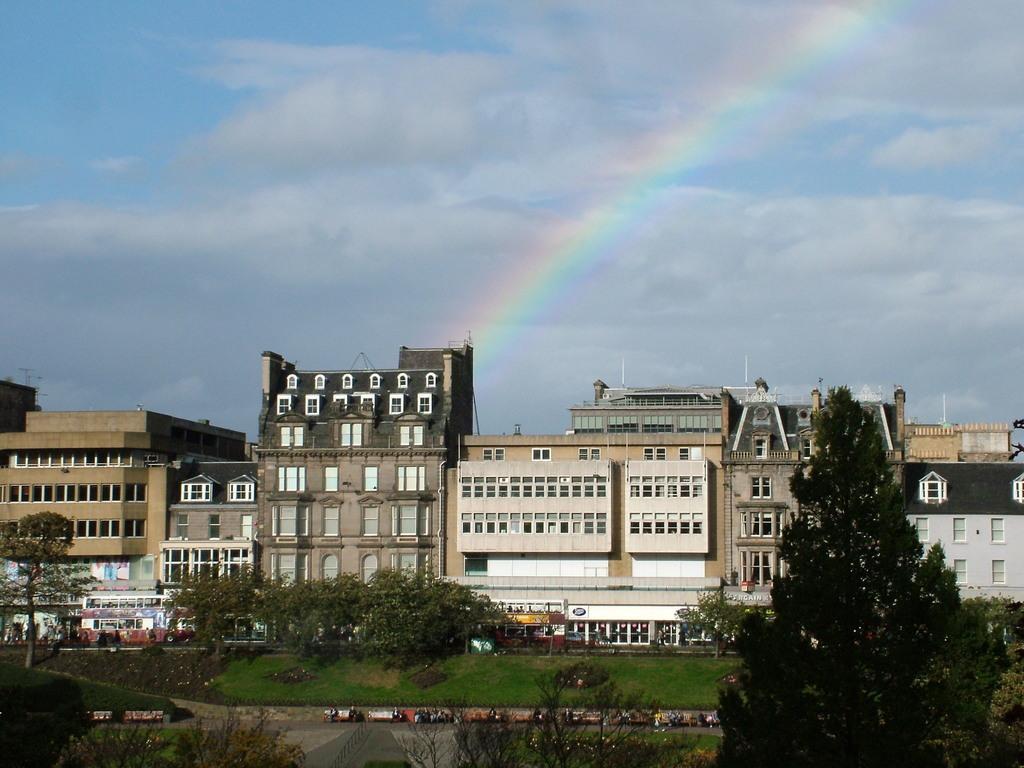How would you summarize this image in a sentence or two? In this image, we can see vehicles on the road and in the background, there are trees and buildings. At the bottom, there is ground and at the top, there is a rainbow and we can see clouds in the sky. 